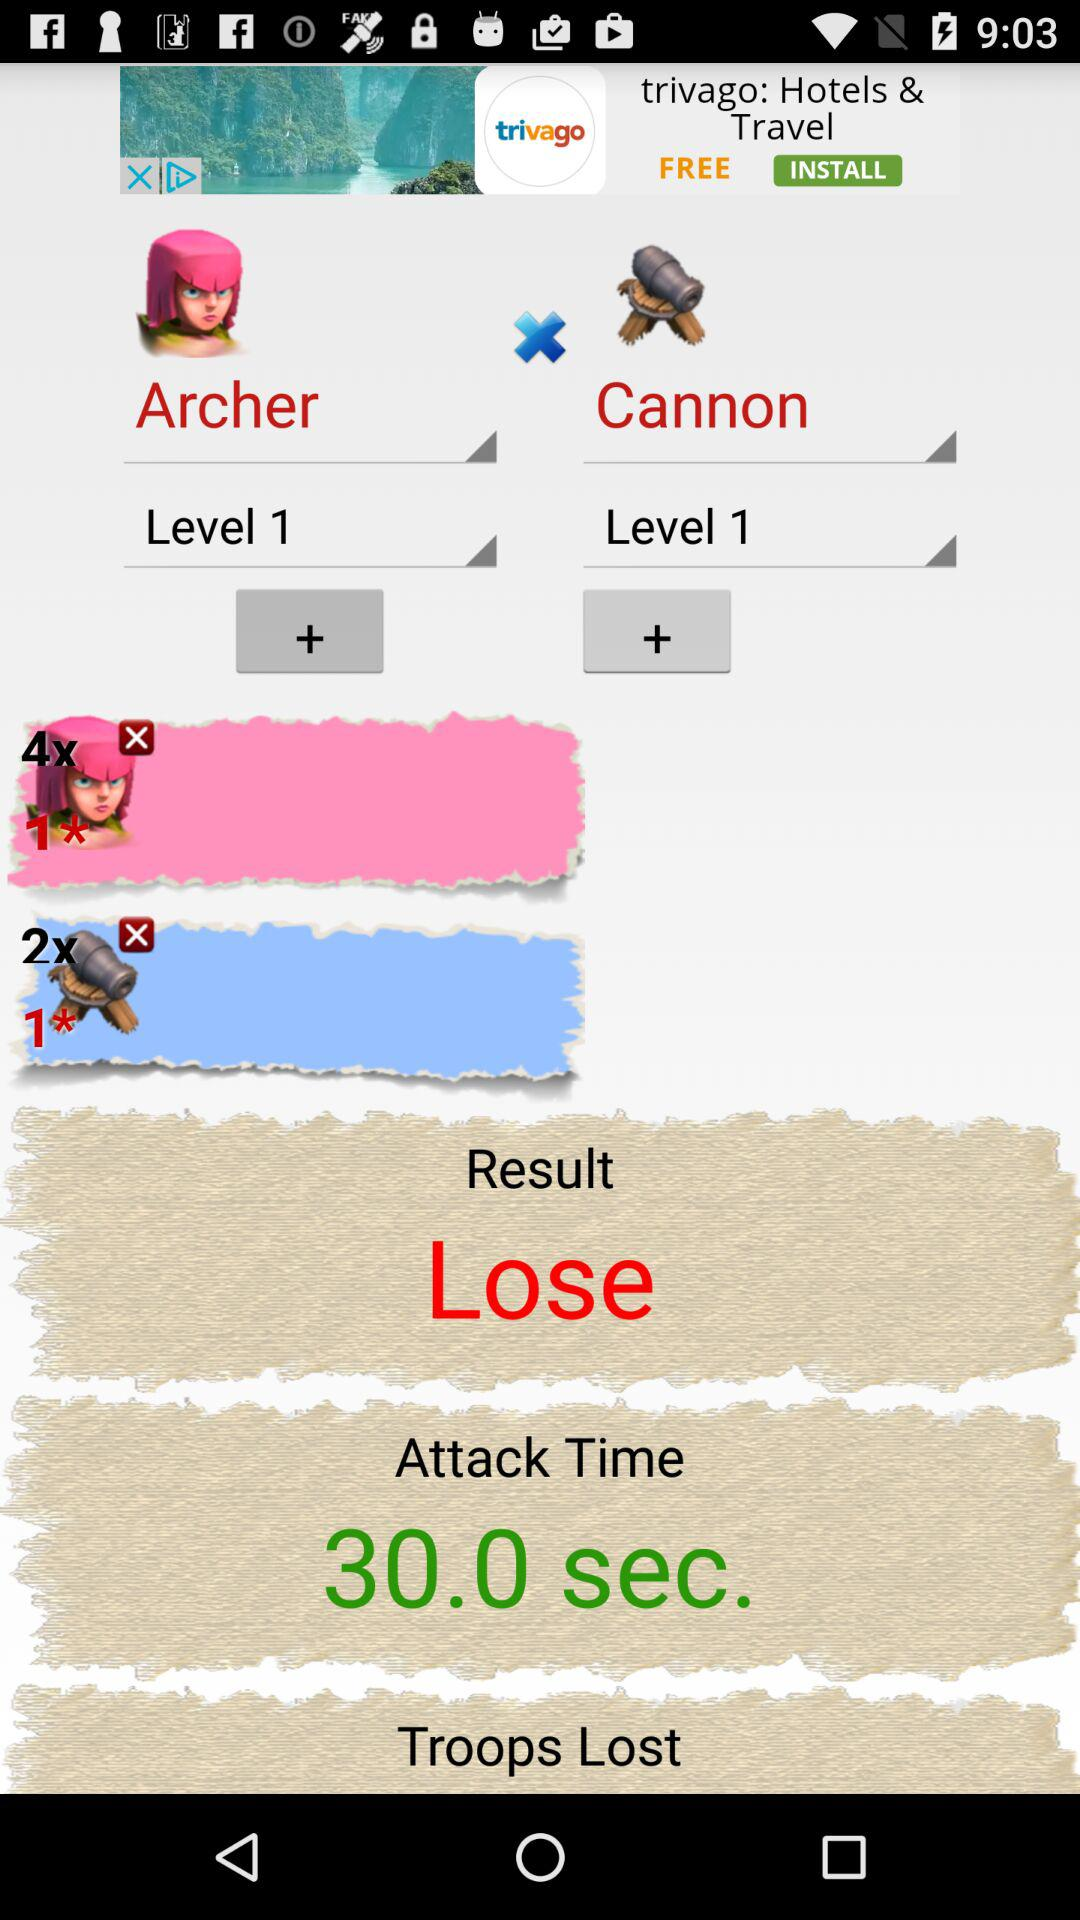How many levels are there in the game?
When the provided information is insufficient, respond with <no answer>. <no answer> 